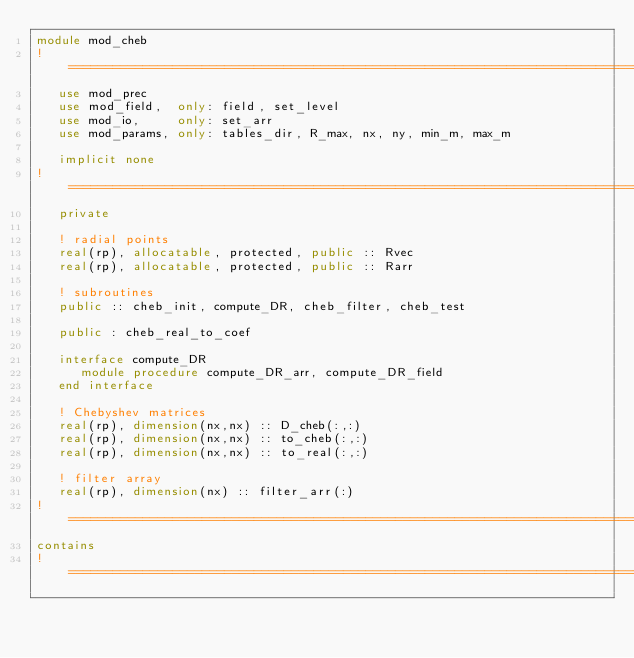<code> <loc_0><loc_0><loc_500><loc_500><_FORTRAN_>module mod_cheb 
!=============================================================================
   use mod_prec
   use mod_field,  only: field, set_level
   use mod_io,     only: set_arr
   use mod_params, only: tables_dir, R_max, nx, ny, min_m, max_m 

   implicit none
!=============================================================================
   private

   ! radial points
   real(rp), allocatable, protected, public :: Rvec
   real(rp), allocatable, protected, public :: Rarr

   ! subroutines
   public :: cheb_init, compute_DR, cheb_filter, cheb_test

   public : cheb_real_to_coef

   interface compute_DR
      module procedure compute_DR_arr, compute_DR_field
   end interface

   ! Chebyshev matrices  
   real(rp), dimension(nx,nx) :: D_cheb(:,:)
   real(rp), dimension(nx,nx) :: to_cheb(:,:)
   real(rp), dimension(nx,nx) :: to_real(:,:)

   ! filter array
   real(rp), dimension(nx) :: filter_arr(:)
!=============================================================================
contains
!=============================================================================</code> 